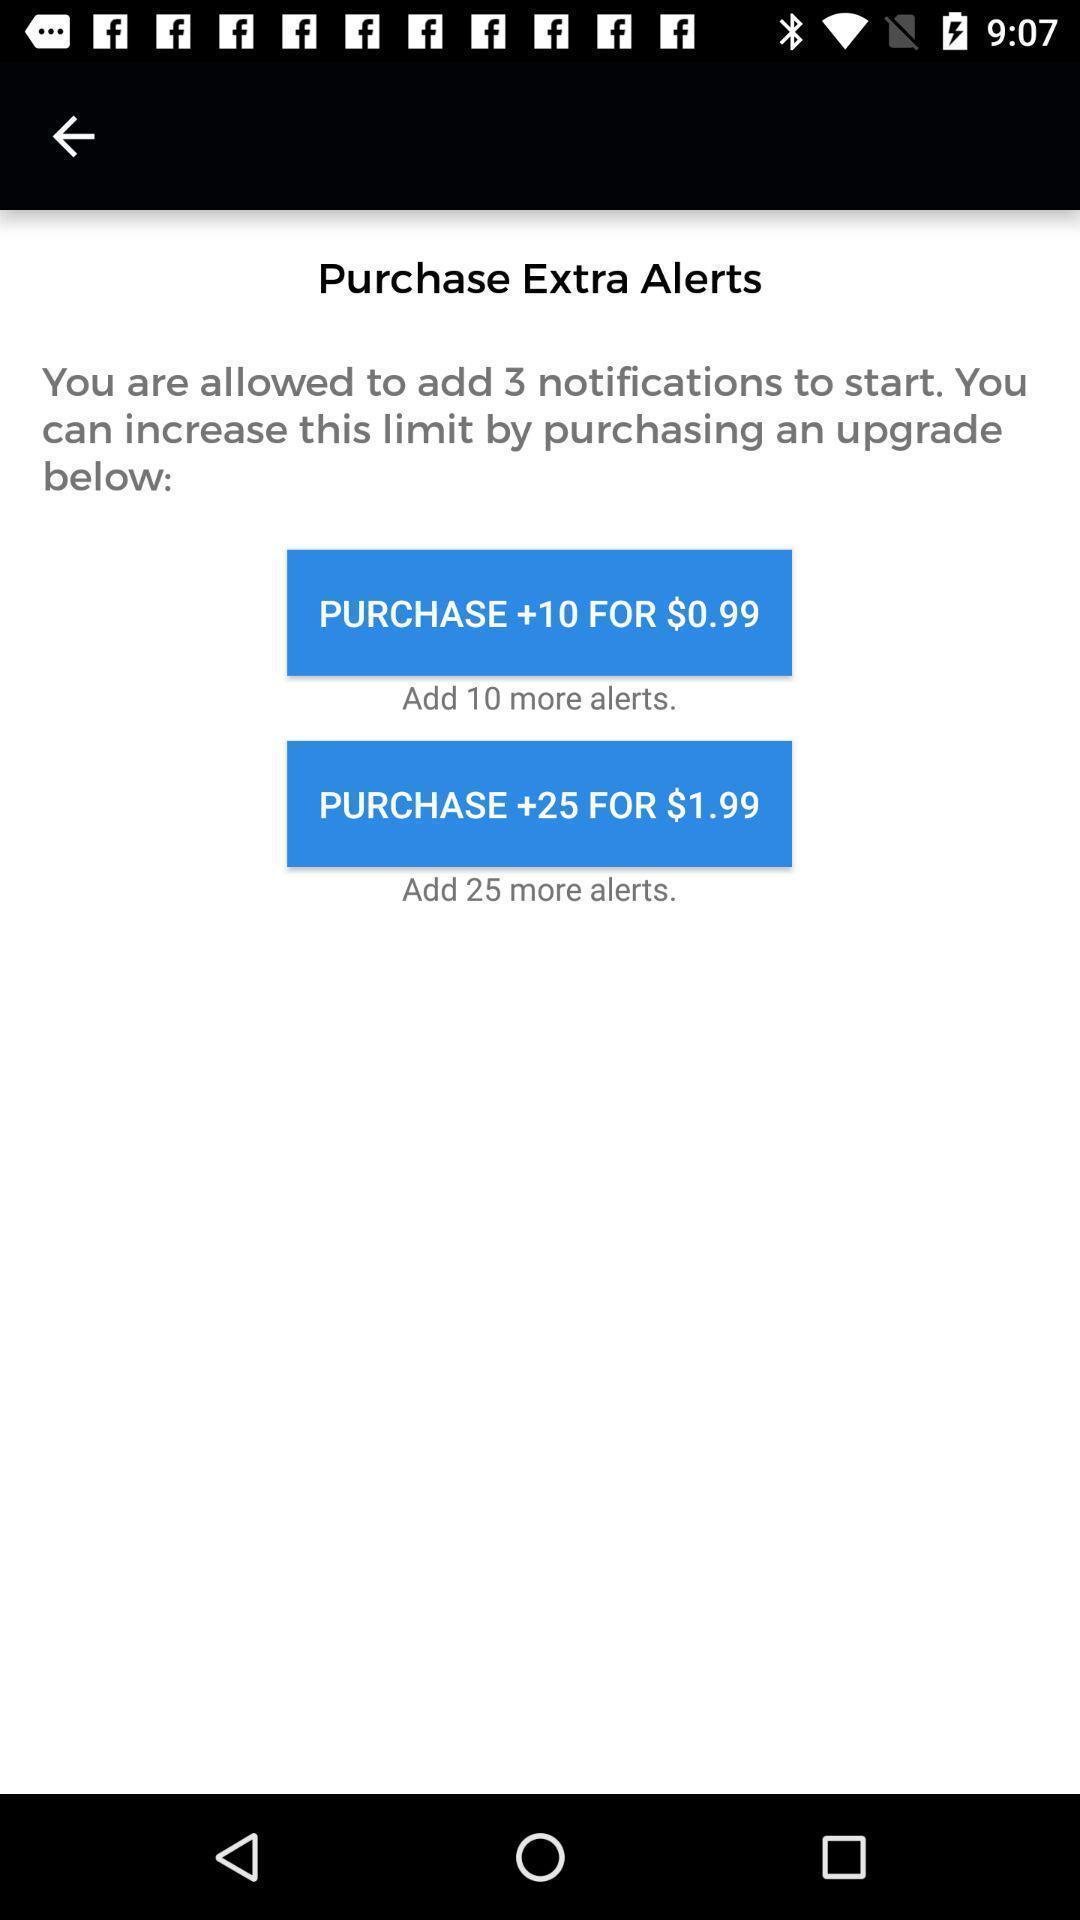Describe the content in this image. Window displaying about purchase page. 